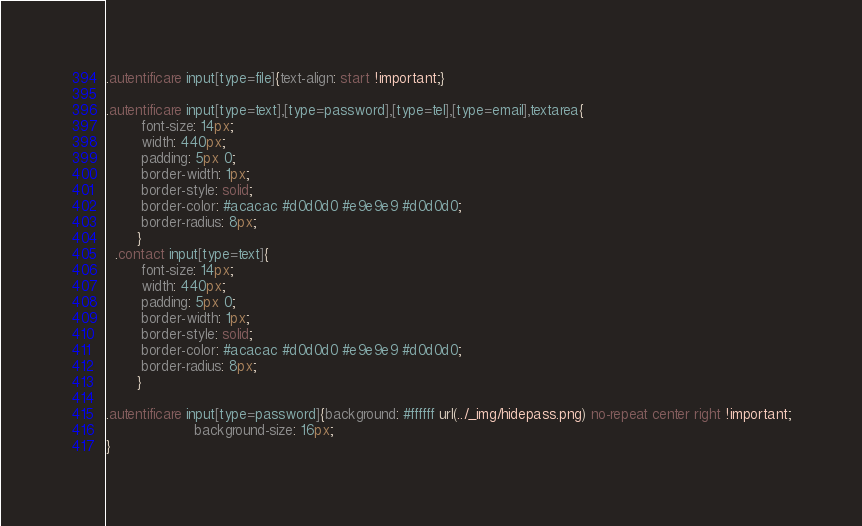Convert code to text. <code><loc_0><loc_0><loc_500><loc_500><_CSS_>

.autentificare input[type=file]{text-align: start !important;}

.autentificare input[type=text],[type=password],[type=tel],[type=email],textarea{
        font-size: 14px;
        width: 440px;
        padding: 5px 0;
        border-width: 1px;
        border-style: solid;
        border-color: #acacac #d0d0d0 #e9e9e9 #d0d0d0;
        border-radius: 8px;
       }
  .contact input[type=text]{
        font-size: 14px;
        width: 440px;
        padding: 5px 0;
        border-width: 1px;
        border-style: solid;
        border-color: #acacac #d0d0d0 #e9e9e9 #d0d0d0;
        border-radius: 8px;
       }

.autentificare input[type=password]{background: #ffffff url(../_img/hidepass.png) no-repeat center right !important;
                    background-size: 16px;
}

</code> 